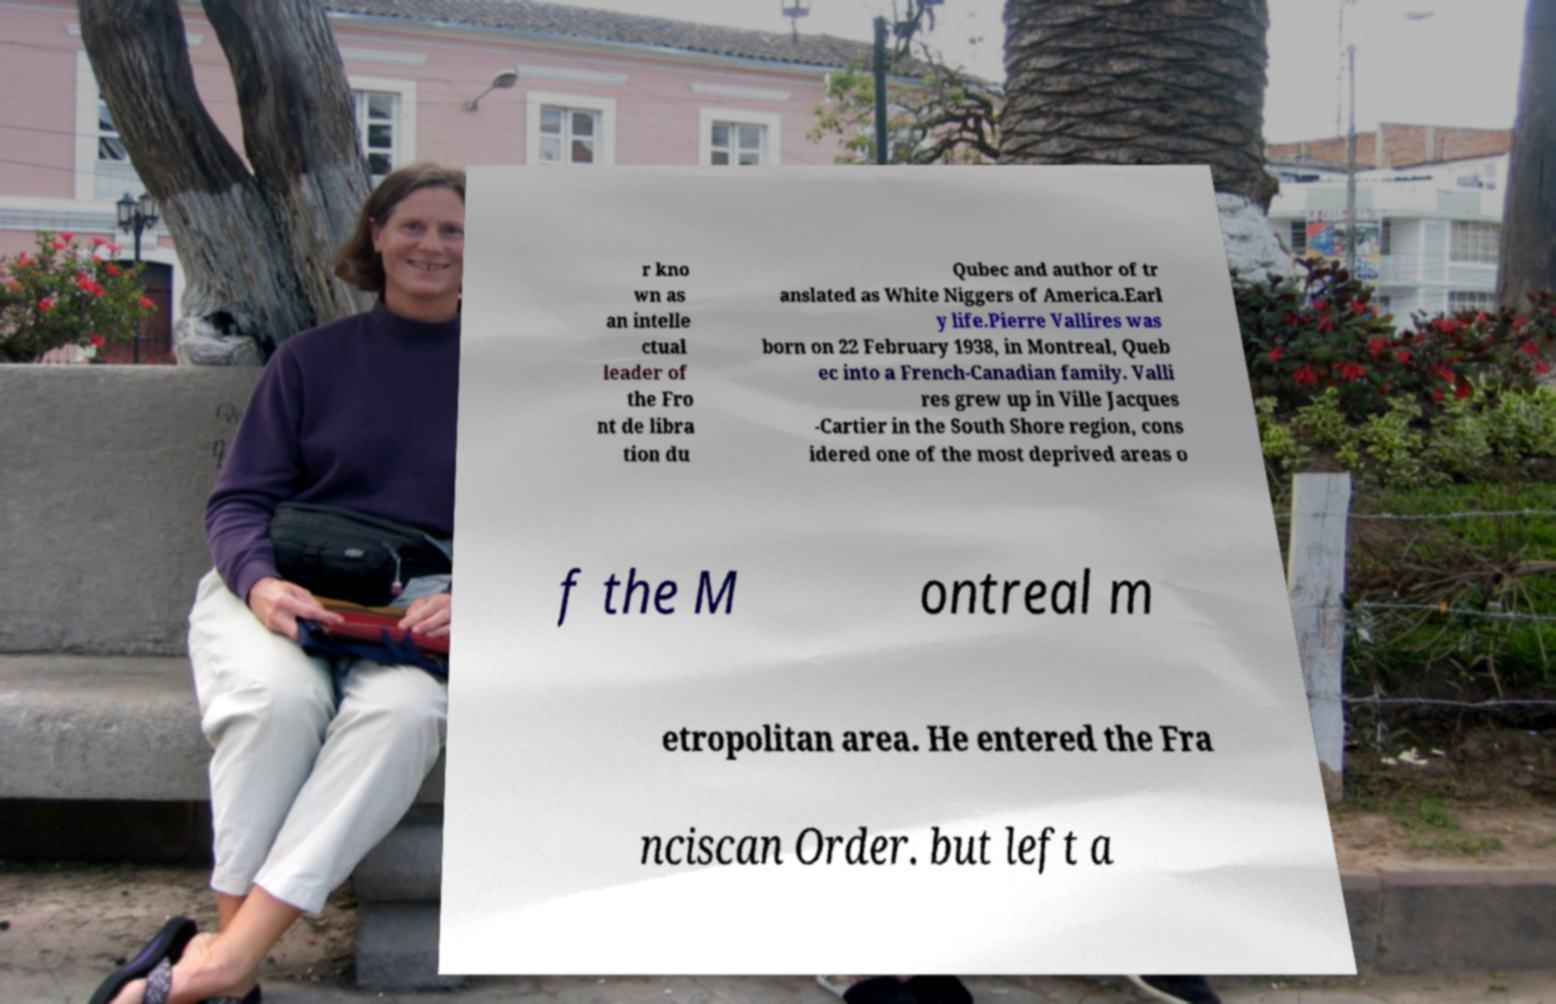Could you assist in decoding the text presented in this image and type it out clearly? r kno wn as an intelle ctual leader of the Fro nt de libra tion du Qubec and author of tr anslated as White Niggers of America.Earl y life.Pierre Vallires was born on 22 February 1938, in Montreal, Queb ec into a French-Canadian family. Valli res grew up in Ville Jacques -Cartier in the South Shore region, cons idered one of the most deprived areas o f the M ontreal m etropolitan area. He entered the Fra nciscan Order. but left a 